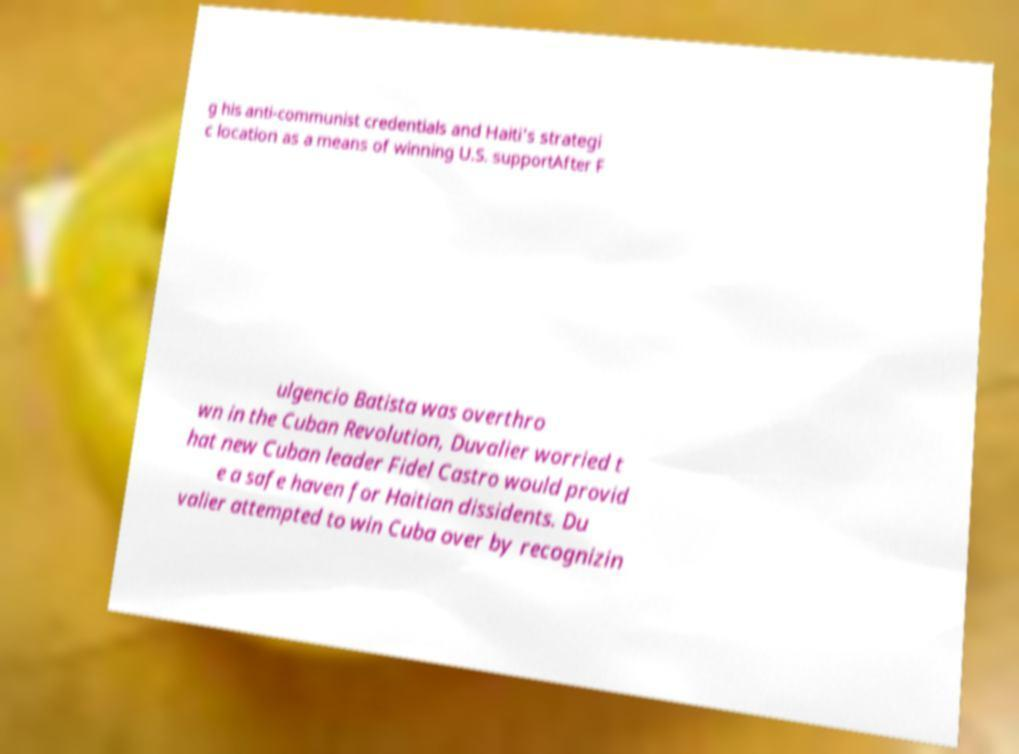Can you read and provide the text displayed in the image?This photo seems to have some interesting text. Can you extract and type it out for me? g his anti-communist credentials and Haiti's strategi c location as a means of winning U.S. supportAfter F ulgencio Batista was overthro wn in the Cuban Revolution, Duvalier worried t hat new Cuban leader Fidel Castro would provid e a safe haven for Haitian dissidents. Du valier attempted to win Cuba over by recognizin 